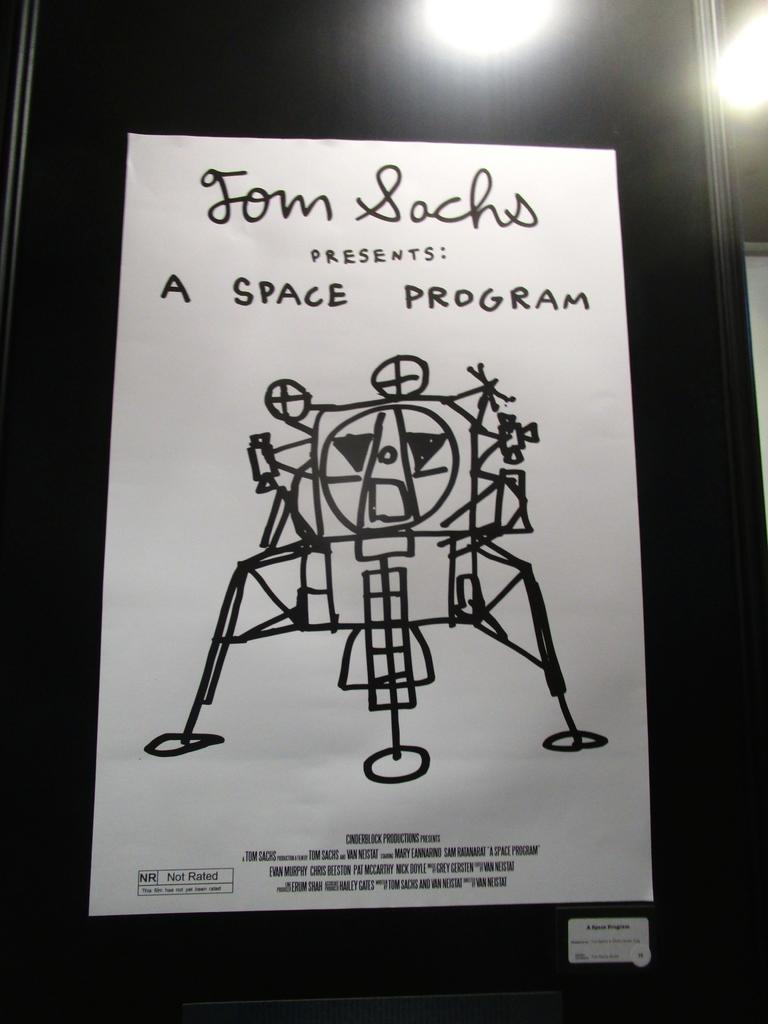What is the main object in the image? There is a poster in the image. What is the color of the surface the poster is on? The poster is on a black surface. What else can be seen in the image besides the poster? There are lights visible in the image. What is depicted on the poster? The poster features a toy. Is there any text on the poster? Yes, there is text on the poster. What type of base is supporting the toy on the poster? There is no base visible in the image, as it only features a poster with a toy and text. 